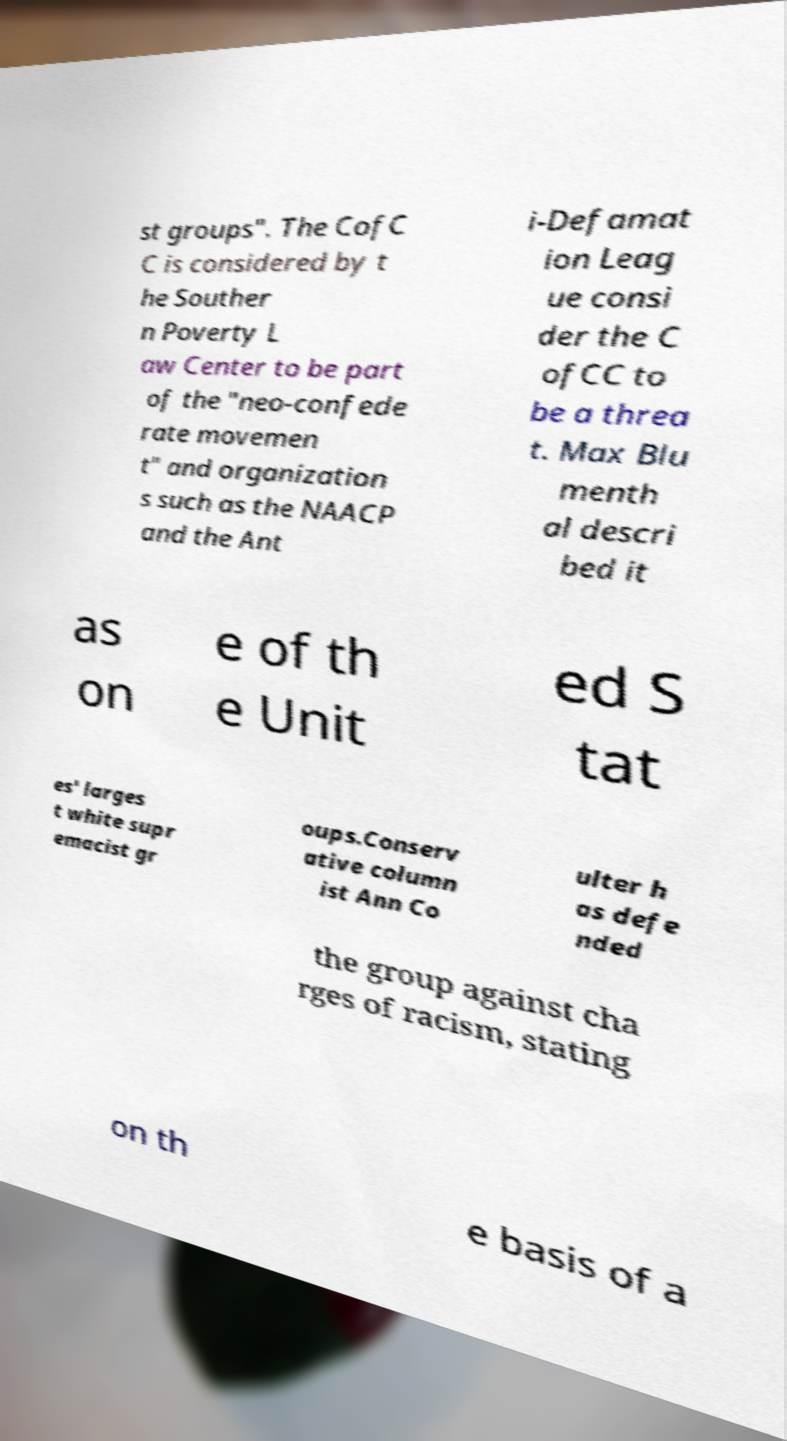Can you accurately transcribe the text from the provided image for me? st groups". The CofC C is considered by t he Souther n Poverty L aw Center to be part of the "neo-confede rate movemen t" and organization s such as the NAACP and the Ant i-Defamat ion Leag ue consi der the C ofCC to be a threa t. Max Blu menth al descri bed it as on e of th e Unit ed S tat es' larges t white supr emacist gr oups.Conserv ative column ist Ann Co ulter h as defe nded the group against cha rges of racism, stating on th e basis of a 